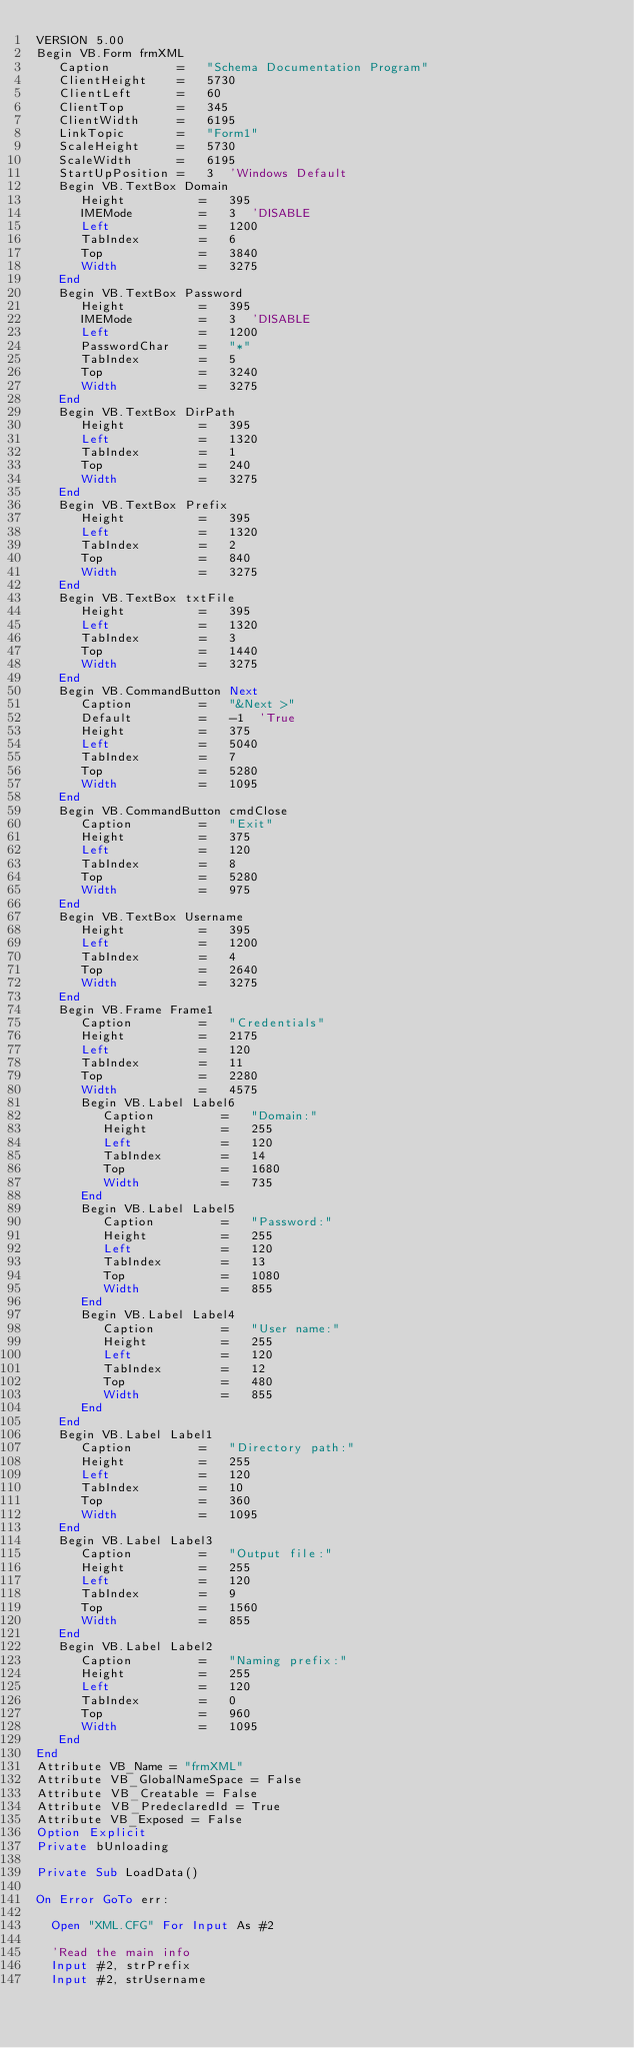<code> <loc_0><loc_0><loc_500><loc_500><_VisualBasic_>VERSION 5.00
Begin VB.Form frmXML 
   Caption         =   "Schema Documentation Program"
   ClientHeight    =   5730
   ClientLeft      =   60
   ClientTop       =   345
   ClientWidth     =   6195
   LinkTopic       =   "Form1"
   ScaleHeight     =   5730
   ScaleWidth      =   6195
   StartUpPosition =   3  'Windows Default
   Begin VB.TextBox Domain 
      Height          =   395
      IMEMode         =   3  'DISABLE
      Left            =   1200
      TabIndex        =   6
      Top             =   3840
      Width           =   3275
   End
   Begin VB.TextBox Password 
      Height          =   395
      IMEMode         =   3  'DISABLE
      Left            =   1200
      PasswordChar    =   "*"
      TabIndex        =   5
      Top             =   3240
      Width           =   3275
   End
   Begin VB.TextBox DirPath 
      Height          =   395
      Left            =   1320
      TabIndex        =   1
      Top             =   240
      Width           =   3275
   End
   Begin VB.TextBox Prefix 
      Height          =   395
      Left            =   1320
      TabIndex        =   2
      Top             =   840
      Width           =   3275
   End
   Begin VB.TextBox txtFile 
      Height          =   395
      Left            =   1320
      TabIndex        =   3
      Top             =   1440
      Width           =   3275
   End
   Begin VB.CommandButton Next 
      Caption         =   "&Next >"
      Default         =   -1  'True
      Height          =   375
      Left            =   5040
      TabIndex        =   7
      Top             =   5280
      Width           =   1095
   End
   Begin VB.CommandButton cmdClose 
      Caption         =   "Exit"
      Height          =   375
      Left            =   120
      TabIndex        =   8
      Top             =   5280
      Width           =   975
   End
   Begin VB.TextBox Username 
      Height          =   395
      Left            =   1200
      TabIndex        =   4
      Top             =   2640
      Width           =   3275
   End
   Begin VB.Frame Frame1 
      Caption         =   "Credentials"
      Height          =   2175
      Left            =   120
      TabIndex        =   11
      Top             =   2280
      Width           =   4575
      Begin VB.Label Label6 
         Caption         =   "Domain:"
         Height          =   255
         Left            =   120
         TabIndex        =   14
         Top             =   1680
         Width           =   735
      End
      Begin VB.Label Label5 
         Caption         =   "Password:"
         Height          =   255
         Left            =   120
         TabIndex        =   13
         Top             =   1080
         Width           =   855
      End
      Begin VB.Label Label4 
         Caption         =   "User name:"
         Height          =   255
         Left            =   120
         TabIndex        =   12
         Top             =   480
         Width           =   855
      End
   End
   Begin VB.Label Label1 
      Caption         =   "Directory path:"
      Height          =   255
      Left            =   120
      TabIndex        =   10
      Top             =   360
      Width           =   1095
   End
   Begin VB.Label Label3 
      Caption         =   "Output file:"
      Height          =   255
      Left            =   120
      TabIndex        =   9
      Top             =   1560
      Width           =   855
   End
   Begin VB.Label Label2 
      Caption         =   "Naming prefix:"
      Height          =   255
      Left            =   120
      TabIndex        =   0
      Top             =   960
      Width           =   1095
   End
End
Attribute VB_Name = "frmXML"
Attribute VB_GlobalNameSpace = False
Attribute VB_Creatable = False
Attribute VB_PredeclaredId = True
Attribute VB_Exposed = False
Option Explicit
Private bUnloading

Private Sub LoadData()

On Error GoTo err:
  
  Open "XML.CFG" For Input As #2
  
  'Read the main info
  Input #2, strPrefix
  Input #2, strUsername</code> 